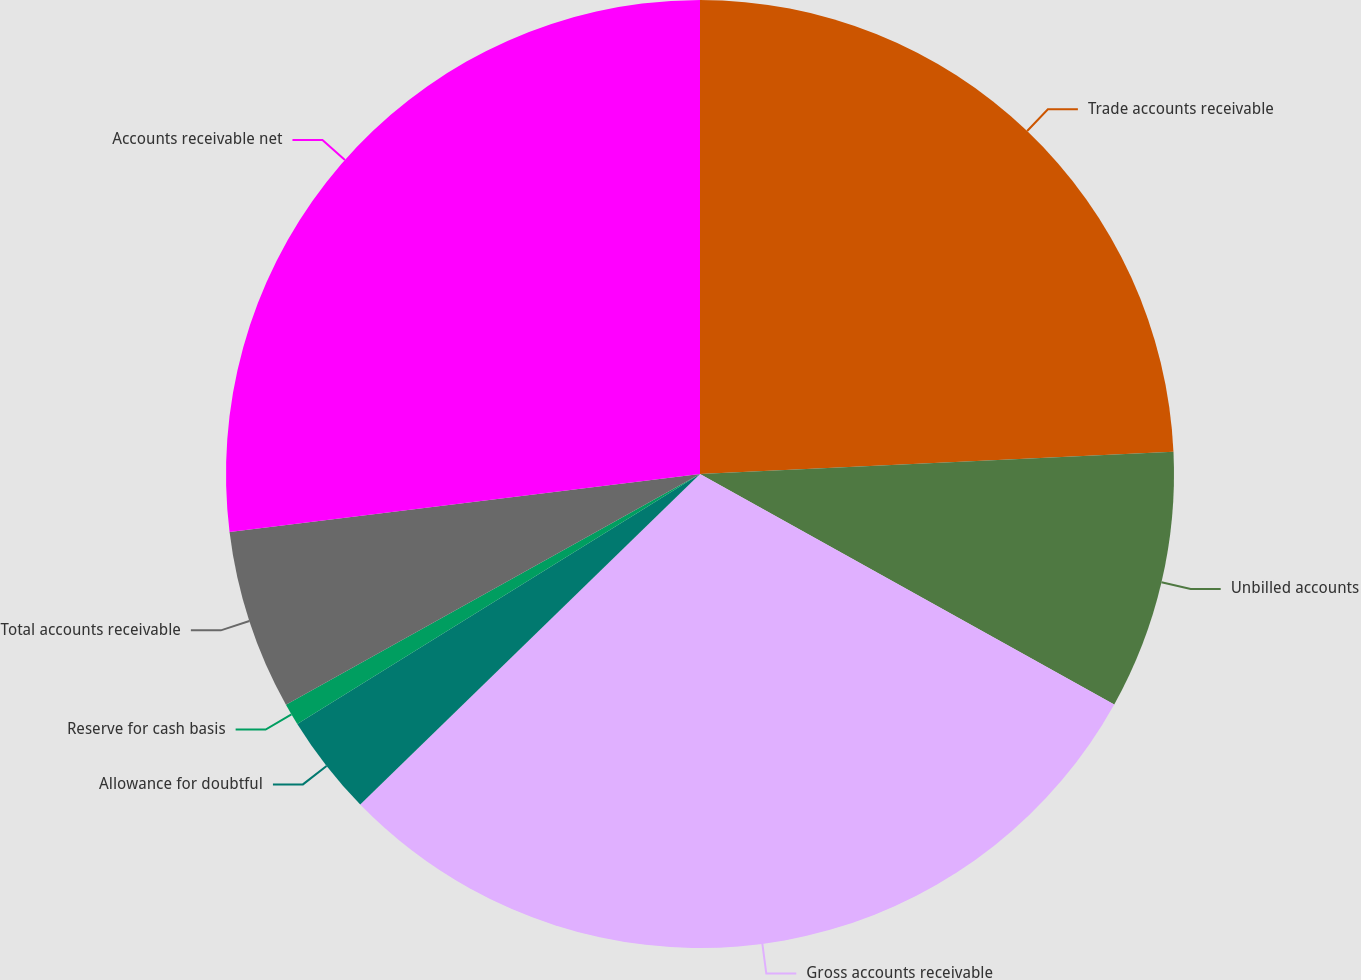Convert chart to OTSL. <chart><loc_0><loc_0><loc_500><loc_500><pie_chart><fcel>Trade accounts receivable<fcel>Unbilled accounts<fcel>Gross accounts receivable<fcel>Allowance for doubtful<fcel>Reserve for cash basis<fcel>Total accounts receivable<fcel>Accounts receivable net<nl><fcel>24.25%<fcel>8.83%<fcel>29.64%<fcel>3.44%<fcel>0.75%<fcel>6.14%<fcel>26.95%<nl></chart> 